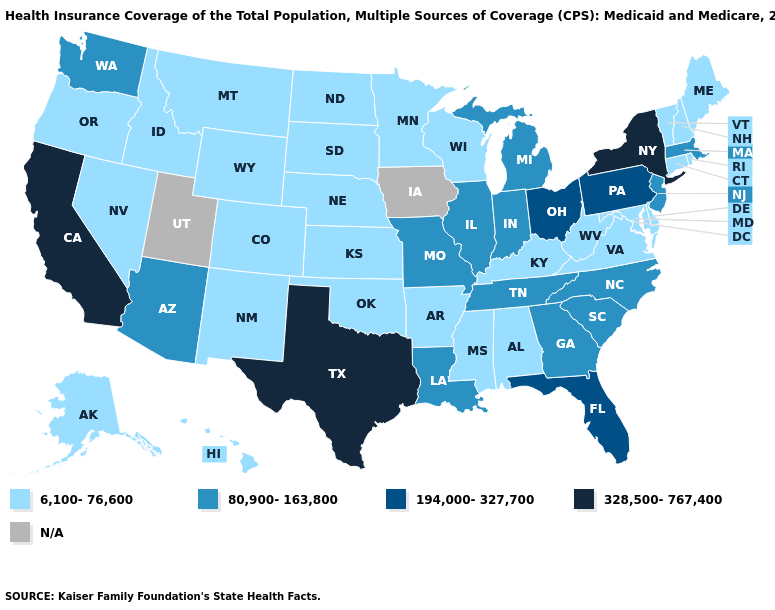Name the states that have a value in the range 6,100-76,600?
Be succinct. Alabama, Alaska, Arkansas, Colorado, Connecticut, Delaware, Hawaii, Idaho, Kansas, Kentucky, Maine, Maryland, Minnesota, Mississippi, Montana, Nebraska, Nevada, New Hampshire, New Mexico, North Dakota, Oklahoma, Oregon, Rhode Island, South Dakota, Vermont, Virginia, West Virginia, Wisconsin, Wyoming. Name the states that have a value in the range 328,500-767,400?
Short answer required. California, New York, Texas. Name the states that have a value in the range 328,500-767,400?
Keep it brief. California, New York, Texas. Is the legend a continuous bar?
Quick response, please. No. Name the states that have a value in the range N/A?
Concise answer only. Iowa, Utah. What is the value of Rhode Island?
Answer briefly. 6,100-76,600. Is the legend a continuous bar?
Quick response, please. No. What is the lowest value in the USA?
Keep it brief. 6,100-76,600. What is the highest value in the USA?
Write a very short answer. 328,500-767,400. Does the map have missing data?
Give a very brief answer. Yes. Which states hav the highest value in the Northeast?
Concise answer only. New York. Name the states that have a value in the range 194,000-327,700?
Quick response, please. Florida, Ohio, Pennsylvania. Does Indiana have the lowest value in the USA?
Concise answer only. No. Name the states that have a value in the range 6,100-76,600?
Answer briefly. Alabama, Alaska, Arkansas, Colorado, Connecticut, Delaware, Hawaii, Idaho, Kansas, Kentucky, Maine, Maryland, Minnesota, Mississippi, Montana, Nebraska, Nevada, New Hampshire, New Mexico, North Dakota, Oklahoma, Oregon, Rhode Island, South Dakota, Vermont, Virginia, West Virginia, Wisconsin, Wyoming. Name the states that have a value in the range N/A?
Short answer required. Iowa, Utah. 